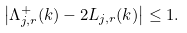Convert formula to latex. <formula><loc_0><loc_0><loc_500><loc_500>\left | \Lambda ^ { + } _ { j , r } ( k ) - 2 L _ { j , r } ( k ) \right | \leq 1 .</formula> 